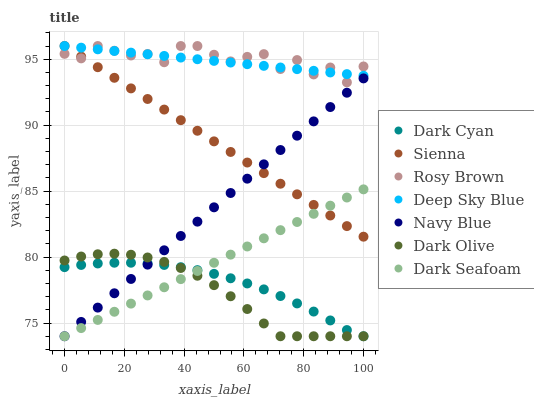Does Dark Olive have the minimum area under the curve?
Answer yes or no. Yes. Does Rosy Brown have the maximum area under the curve?
Answer yes or no. Yes. Does Navy Blue have the minimum area under the curve?
Answer yes or no. No. Does Navy Blue have the maximum area under the curve?
Answer yes or no. No. Is Deep Sky Blue the smoothest?
Answer yes or no. Yes. Is Rosy Brown the roughest?
Answer yes or no. Yes. Is Navy Blue the smoothest?
Answer yes or no. No. Is Navy Blue the roughest?
Answer yes or no. No. Does Dark Olive have the lowest value?
Answer yes or no. Yes. Does Rosy Brown have the lowest value?
Answer yes or no. No. Does Deep Sky Blue have the highest value?
Answer yes or no. Yes. Does Navy Blue have the highest value?
Answer yes or no. No. Is Dark Olive less than Rosy Brown?
Answer yes or no. Yes. Is Deep Sky Blue greater than Navy Blue?
Answer yes or no. Yes. Does Dark Olive intersect Dark Cyan?
Answer yes or no. Yes. Is Dark Olive less than Dark Cyan?
Answer yes or no. No. Is Dark Olive greater than Dark Cyan?
Answer yes or no. No. Does Dark Olive intersect Rosy Brown?
Answer yes or no. No. 